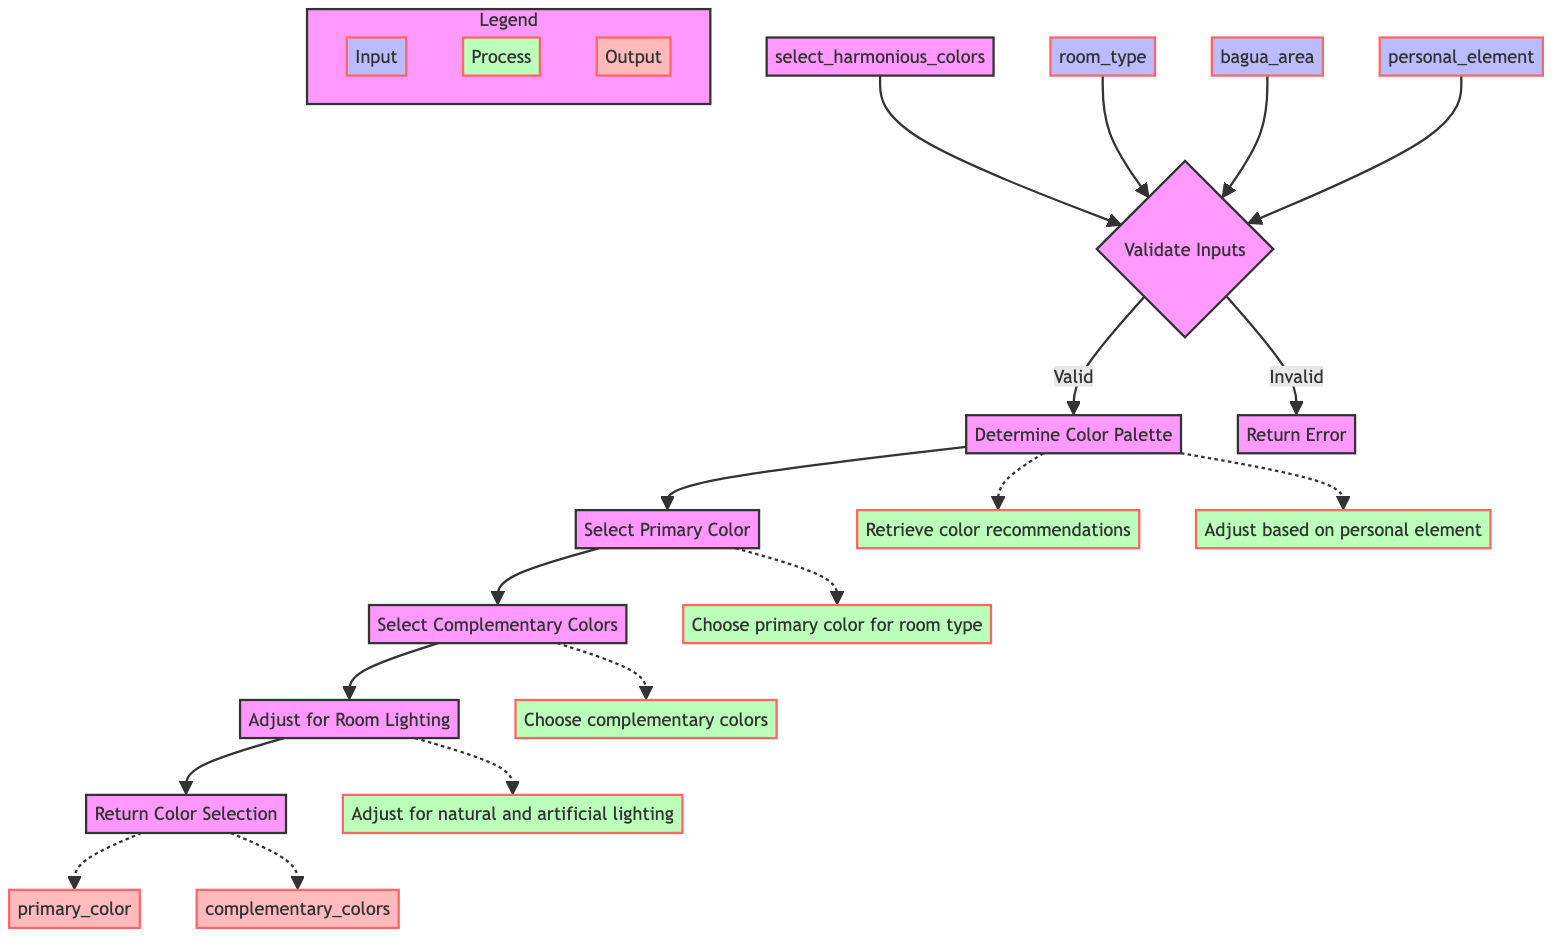What is the name of the main function in the diagram? The main function is represented at the start of the flowchart and is labeled as 'select_harmonious_colors'.
Answer: select_harmonious_colors What are the three parameters required by the function? The parameters listed in the diagram are 'room_type', 'bagua_area', and 'personal_element'.
Answer: room_type, bagua_area, personal_element How many steps are there in the process flow? By examining the flow of the diagram, we identify five distinct steps: Validate Inputs, Determine Color Palette, Select Primary Color, Select Complementary Colors, and Adjust for Room Lighting.
Answer: 5 What does the function return? The return type of the function is described as a dictionary containing 'primary_color' and 'complementary_colors', indicating what results are produced upon completion.
Answer: dict What is the first step in the process? The flowchart clearly indicates that the first step to be undertaken after function initiation is to 'Validate Inputs'.
Answer: Validate Inputs If the inputs are invalid, what happens next? The diagram shows that if the inputs are invalid, the flow leads to the node labeled 'Return Error', indicating the outcome of invalid inputs.
Answer: Return Error Which step directly follows determining the color palette? From the flowchart, following the 'Determine Color Palette' step, we proceed directly to the 'Select Primary Color' step.
Answer: Select Primary Color How does the process adjust the selected colors? It is indicated in the final steps of the flowchart that colors are adjusted based on the natural and artificial lighting of the room.
Answer: Adjust for Room Lighting What is the purpose of the 'Select Complementary Colors' step? This step is utilized to choose complementary colors that support a balanced energy distribution alongside the primary color selected earlier.
Answer: Balanced energy distribution What are the output keys of the returned dictionary? The flowchart specifies that the output keys are 'primary_color' and 'complementary_colors'.
Answer: primary_color, complementary_colors 